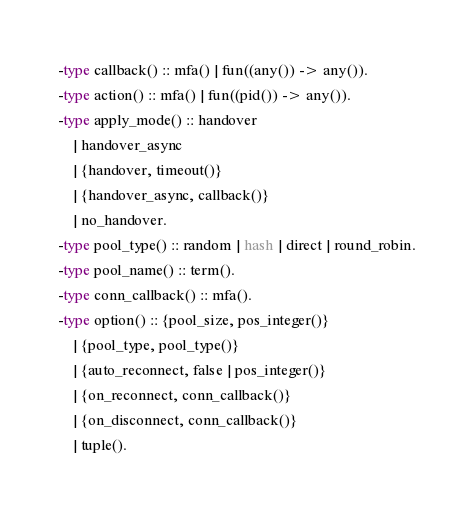<code> <loc_0><loc_0><loc_500><loc_500><_Erlang_>-type callback() :: mfa() | fun((any()) -> any()).
-type action() :: mfa() | fun((pid()) -> any()).
-type apply_mode() :: handover
    | handover_async
    | {handover, timeout()}
    | {handover_async, callback()}
    | no_handover.
-type pool_type() :: random | hash | direct | round_robin.
-type pool_name() :: term().
-type conn_callback() :: mfa().
-type option() :: {pool_size, pos_integer()}
    | {pool_type, pool_type()}
    | {auto_reconnect, false | pos_integer()}
    | {on_reconnect, conn_callback()}
    | {on_disconnect, conn_callback()}
    | tuple().
</code> 